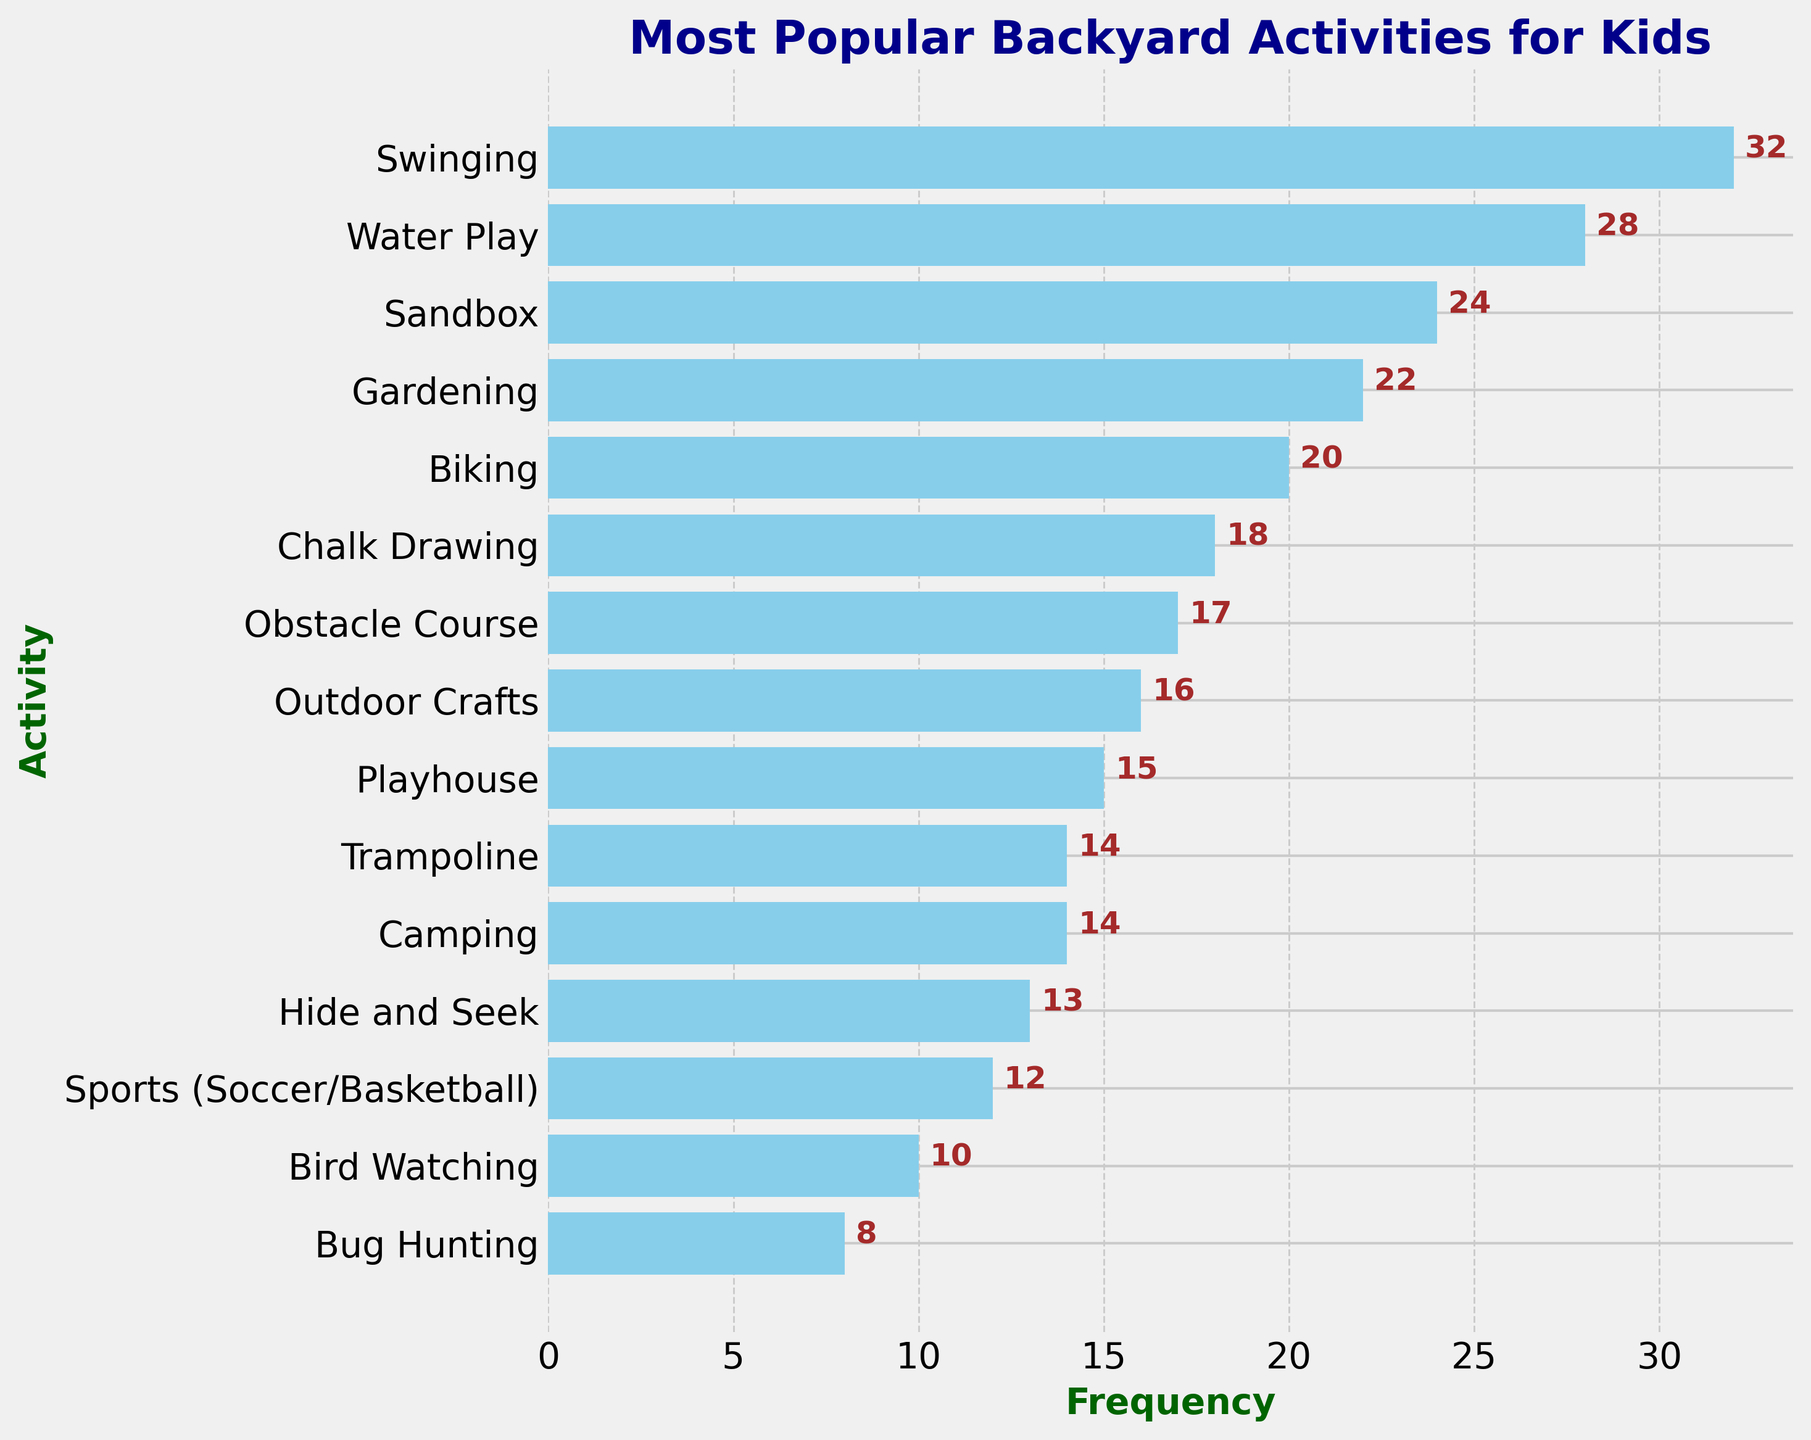Which activity has the highest frequency? By looking at the figure, identify the tallest bar, which represents the activity with the highest frequency. The tallest bar corresponds to the "Swinging" activity.
Answer: Swinging What is the combined frequency of 'Gardening' and 'Biking'? Find the bars representing 'Gardening' and 'Biking', read their frequencies (22 for 'Gardening' and 20 for 'Biking'), and then add them together. 22 + 20 = 42.
Answer: 42 How does 'Water Play' compare to 'Sandbox' in terms of frequency? Compare the heights of the bars for 'Water Play' and 'Sandbox'. 'Water Play' has a taller bar (frequency 28) compared to 'Sandbox' (frequency 24).
Answer: Water Play has a higher frequency Which activities have a frequency higher than 20? Identify the bars with frequencies greater than 20. 'Swinging', 'Water Play', 'Sandbox', and 'Gardening' all have frequencies greater than 20.
Answer: Swinging, Water Play, Sandbox, Gardening What is the difference in frequency between the activities 'Obstacle Course' and 'Playhouse'? Find the bars representing 'Obstacle Course' (frequency 17) and 'Playhouse' (frequency 15) and calculate the difference. 17 - 15 = 2.
Answer: 2 Which activity has a frequency that is closest to the average frequency of all activities? Calculate the average frequency of all activities and identify the activity with a frequency closest to this value. The sum of all frequencies is 283, and there are 15 activities, so the average is 283 / 15 ≈ 18.87. The closest frequency is 'Chalk Drawing' with a frequency of 18.
Answer: Chalk Drawing What is the median value of the frequencies? First, order the list of frequencies. The ordered frequencies are: 8, 10, 12, 13, 14, 14, 15, 16, 17, 18, 20, 22, 24, 28, 32. With an odd number of activities (15), the median is the middle value, which is 17.
Answer: 17 How many activities have a frequency of less than 15? Count the bars representing activities with frequencies less than 15. 'Camping', 'Trampoline', 'Hide and Seek', 'Sports (Soccer/Basketball)', 'Bird Watching', and 'Bug Hunting' all have frequencies less than 15, making a total of 6.
Answer: 6 What is the total frequency of activities related to nature (Gardening, Bird Watching, Bug Hunting)? Sum the frequencies of 'Gardening' (22), 'Bird Watching' (10), and 'Bug Hunting' (8). 22 + 10 + 8 = 40.
Answer: 40 Which activity has the second-lowest frequency? Identify the bar that represents the second-lowest frequency. The lowest frequency is 'Bug Hunting' with 8, and the second-lowest is 'Bird Watching' with 10.
Answer: Bird Watching 